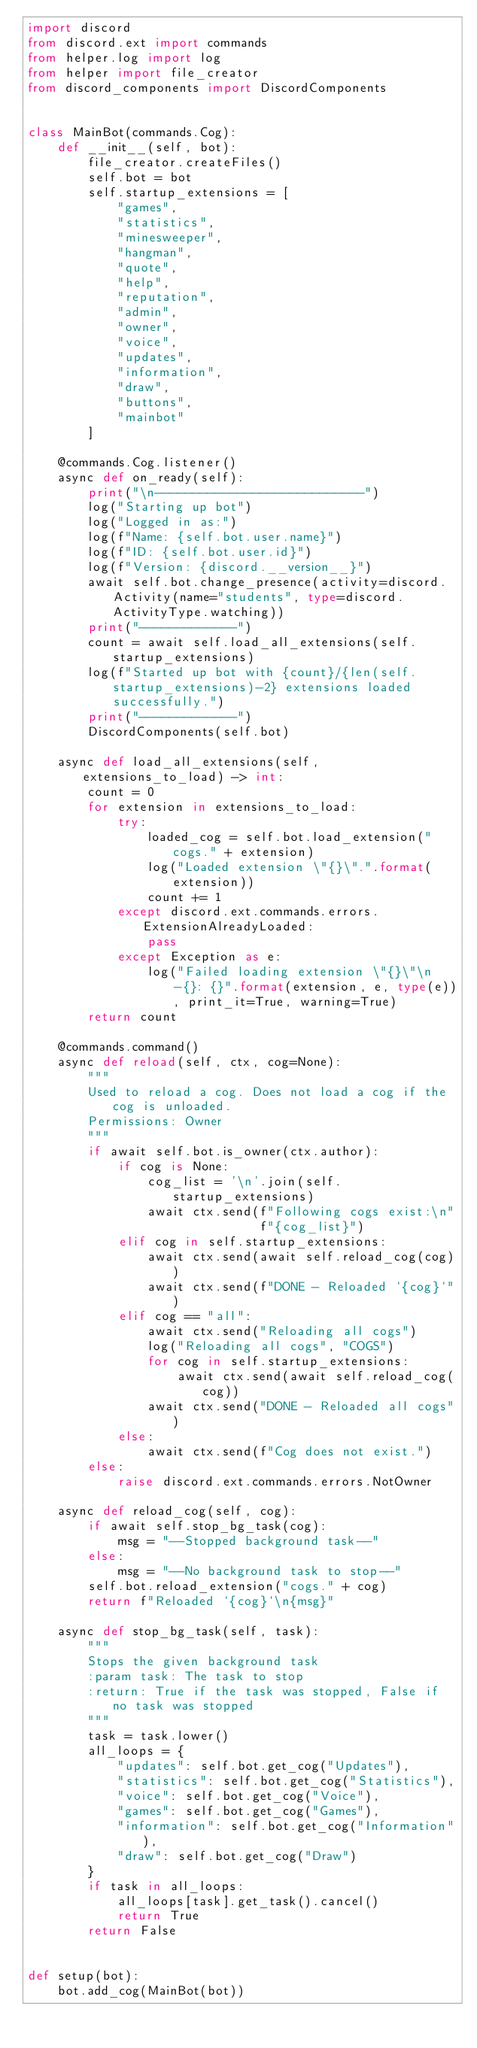Convert code to text. <code><loc_0><loc_0><loc_500><loc_500><_Python_>import discord
from discord.ext import commands
from helper.log import log
from helper import file_creator
from discord_components import DiscordComponents


class MainBot(commands.Cog):
    def __init__(self, bot):
        file_creator.createFiles()
        self.bot = bot
        self.startup_extensions = [
            "games",
            "statistics",
            "minesweeper",
            "hangman",
            "quote",
            "help",
            "reputation",
            "admin",
            "owner",
            "voice",
            "updates",
            "information",
            "draw",
            "buttons",
            "mainbot"
        ]

    @commands.Cog.listener()
    async def on_ready(self):
        print("\n----------------------------")
        log("Starting up bot")
        log("Logged in as:")
        log(f"Name: {self.bot.user.name}")
        log(f"ID: {self.bot.user.id}")
        log(f"Version: {discord.__version__}")
        await self.bot.change_presence(activity=discord.Activity(name="students", type=discord.ActivityType.watching))
        print("-------------")
        count = await self.load_all_extensions(self.startup_extensions)
        log(f"Started up bot with {count}/{len(self.startup_extensions)-2} extensions loaded successfully.")
        print("-------------")
        DiscordComponents(self.bot)

    async def load_all_extensions(self, extensions_to_load) -> int:
        count = 0
        for extension in extensions_to_load:
            try:
                loaded_cog = self.bot.load_extension("cogs." + extension)
                log("Loaded extension \"{}\".".format(extension))
                count += 1
            except discord.ext.commands.errors.ExtensionAlreadyLoaded:
                pass
            except Exception as e:
                log("Failed loading extension \"{}\"\n-{}: {}".format(extension, e, type(e)), print_it=True, warning=True)
        return count

    @commands.command()
    async def reload(self, ctx, cog=None):
        """
        Used to reload a cog. Does not load a cog if the cog is unloaded.
        Permissions: Owner
        """
        if await self.bot.is_owner(ctx.author):
            if cog is None:
                cog_list = '\n'.join(self.startup_extensions)
                await ctx.send(f"Following cogs exist:\n"
                               f"{cog_list}")
            elif cog in self.startup_extensions:
                await ctx.send(await self.reload_cog(cog))
                await ctx.send(f"DONE - Reloaded `{cog}`")
            elif cog == "all":
                await ctx.send("Reloading all cogs")
                log("Reloading all cogs", "COGS")
                for cog in self.startup_extensions:
                    await ctx.send(await self.reload_cog(cog))
                await ctx.send("DONE - Reloaded all cogs")
            else:
                await ctx.send(f"Cog does not exist.")
        else:
            raise discord.ext.commands.errors.NotOwner

    async def reload_cog(self, cog):
        if await self.stop_bg_task(cog):
            msg = "--Stopped background task--"
        else:
            msg = "--No background task to stop--"
        self.bot.reload_extension("cogs." + cog)
        return f"Reloaded `{cog}`\n{msg}"

    async def stop_bg_task(self, task):
        """
        Stops the given background task
        :param task: The task to stop
        :return: True if the task was stopped, False if no task was stopped
        """
        task = task.lower()
        all_loops = {
            "updates": self.bot.get_cog("Updates"),
            "statistics": self.bot.get_cog("Statistics"),
            "voice": self.bot.get_cog("Voice"),
            "games": self.bot.get_cog("Games"),
            "information": self.bot.get_cog("Information"),
            "draw": self.bot.get_cog("Draw")
        }
        if task in all_loops:
            all_loops[task].get_task().cancel()
            return True
        return False


def setup(bot):
    bot.add_cog(MainBot(bot))
</code> 